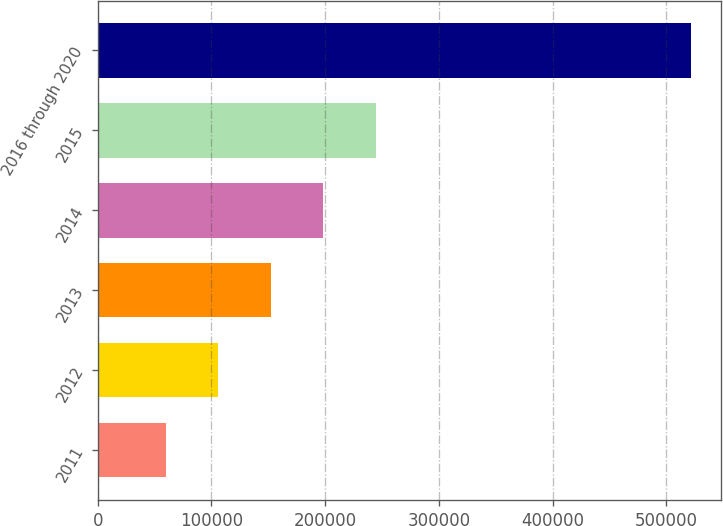Convert chart to OTSL. <chart><loc_0><loc_0><loc_500><loc_500><bar_chart><fcel>2011<fcel>2012<fcel>2013<fcel>2014<fcel>2015<fcel>2016 through 2020<nl><fcel>59966<fcel>106159<fcel>152352<fcel>198545<fcel>244738<fcel>521897<nl></chart> 